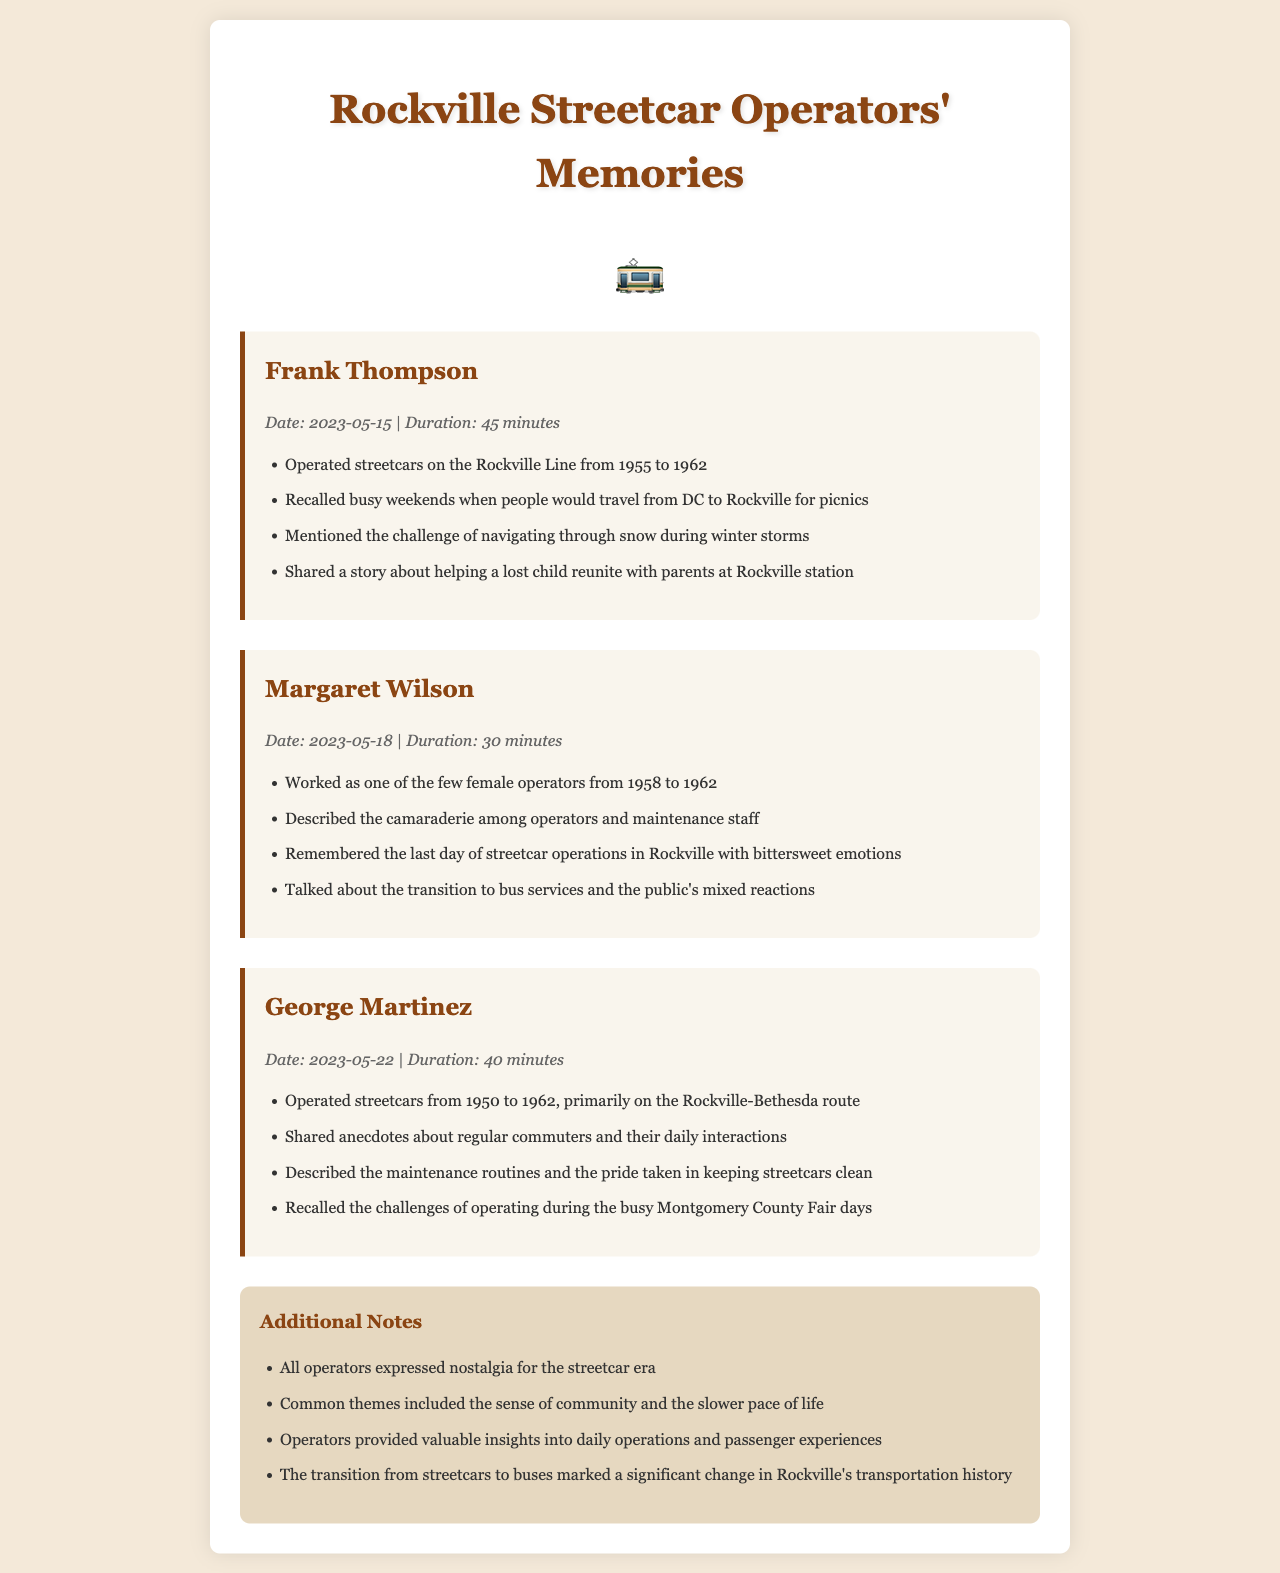what is the name of the first operator mentioned? The document lists Frank Thompson as the first operator in the records.
Answer: Frank Thompson what was the date of George Martinez's call? The call with George Martinez took place on May 22, 2023.
Answer: 2023-05-22 how long did Margaret Wilson's call last? The duration of Margaret Wilson's call is specified as 30 minutes.
Answer: 30 minutes what year did Frank Thompson operate streetcars until? Frank Thompson operated streetcars until 1962, as mentioned in the document.
Answer: 1962 what challenge did Frank Thompson mention during his operation? Frank Thompson recalled the challenge of navigating through snow during winter storms.
Answer: navigating through snow what emotional tone was associated with the last day of streetcar operations? The document indicates that Margaret Wilson felt bittersweet emotions on the last day of operations.
Answer: bittersweet how many minutes did George Martinez's call last? The duration of George Martinez's call is noted as 40 minutes.
Answer: 40 minutes what common theme did all operators express? All operators expressed nostalgia for the streetcar era, as noted in the additional notes section.
Answer: nostalgia which route did George Martinez primarily operate on? George Martinez primarily operated on the Rockville-Bethesda route, as mentioned.
Answer: Rockville-Bethesda route 